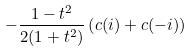<formula> <loc_0><loc_0><loc_500><loc_500>- \frac { 1 - t ^ { 2 } } { 2 ( 1 + t ^ { 2 } ) } \left ( c ( i ) + c ( - i ) \right )</formula> 